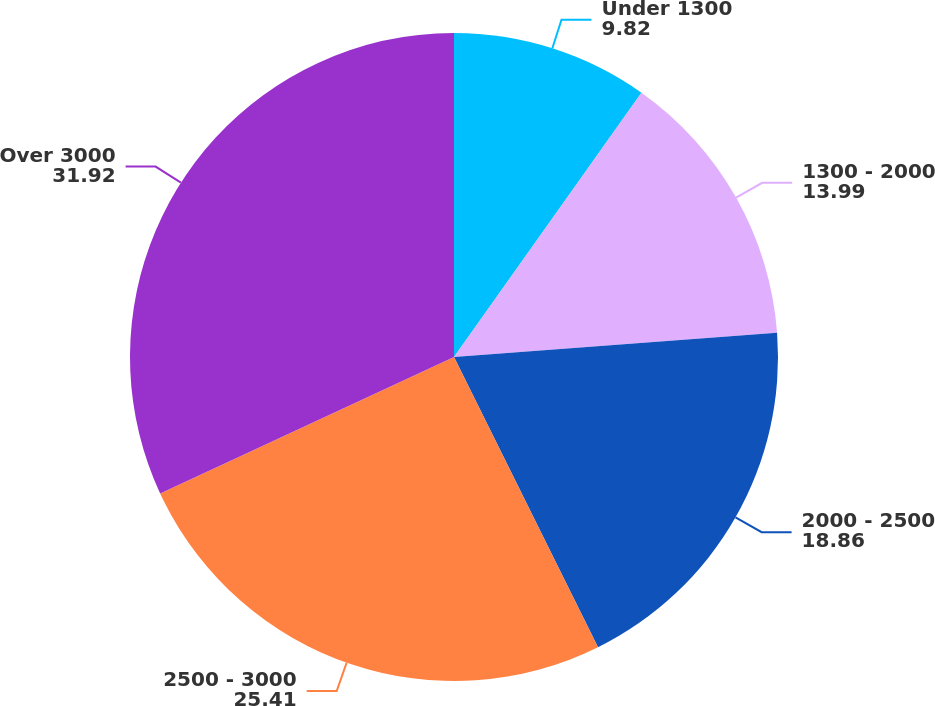Convert chart. <chart><loc_0><loc_0><loc_500><loc_500><pie_chart><fcel>Under 1300<fcel>1300 - 2000<fcel>2000 - 2500<fcel>2500 - 3000<fcel>Over 3000<nl><fcel>9.82%<fcel>13.99%<fcel>18.86%<fcel>25.41%<fcel>31.92%<nl></chart> 